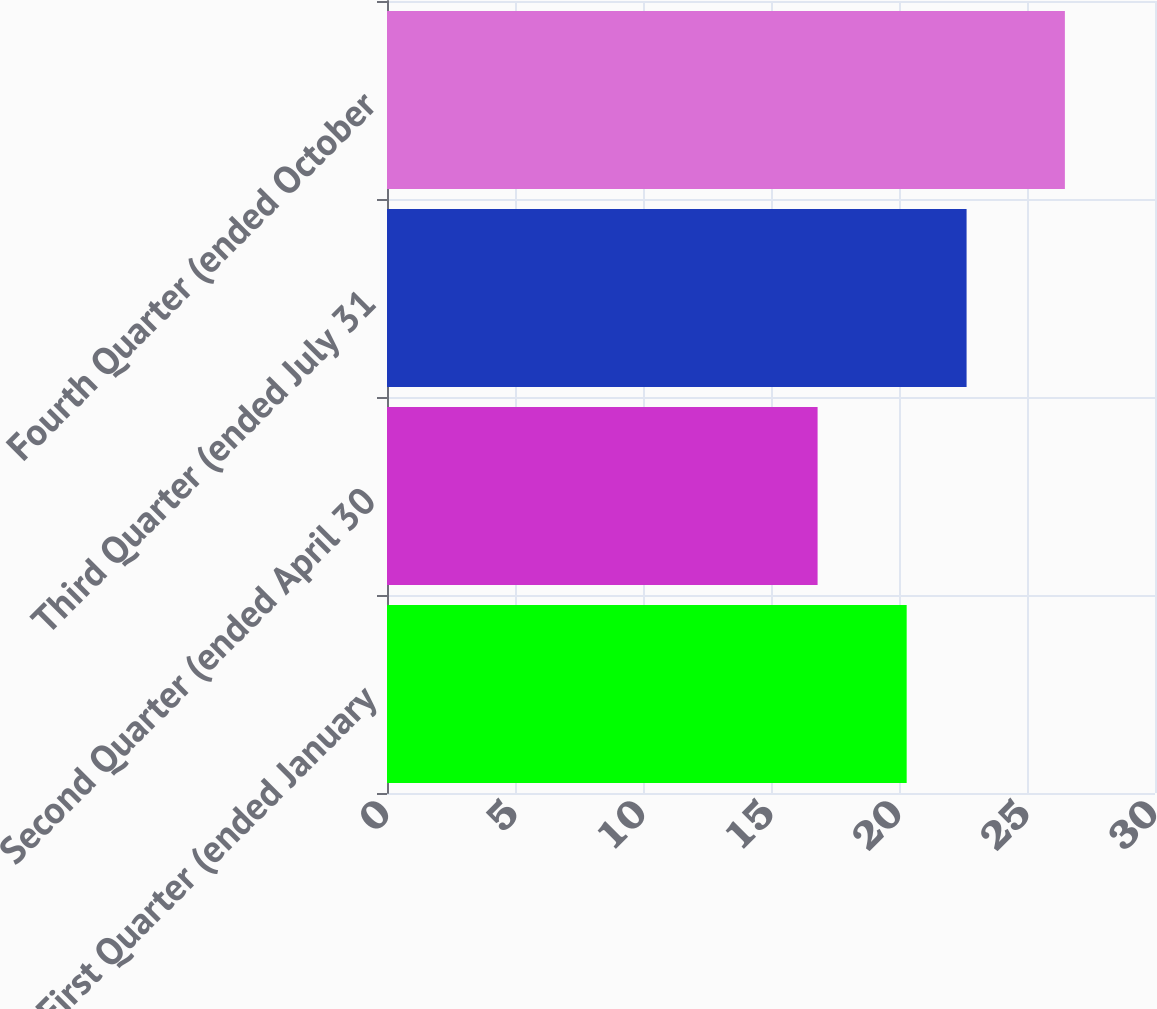<chart> <loc_0><loc_0><loc_500><loc_500><bar_chart><fcel>First Quarter (ended January<fcel>Second Quarter (ended April 30<fcel>Third Quarter (ended July 31<fcel>Fourth Quarter (ended October<nl><fcel>20.3<fcel>16.82<fcel>22.64<fcel>26.48<nl></chart> 